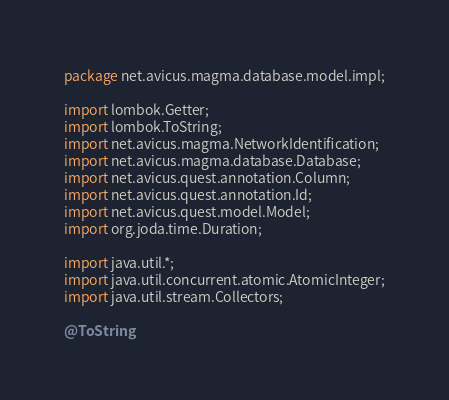Convert code to text. <code><loc_0><loc_0><loc_500><loc_500><_Java_>package net.avicus.magma.database.model.impl;

import lombok.Getter;
import lombok.ToString;
import net.avicus.magma.NetworkIdentification;
import net.avicus.magma.database.Database;
import net.avicus.quest.annotation.Column;
import net.avicus.quest.annotation.Id;
import net.avicus.quest.model.Model;
import org.joda.time.Duration;

import java.util.*;
import java.util.concurrent.atomic.AtomicInteger;
import java.util.stream.Collectors;

@ToString</code> 